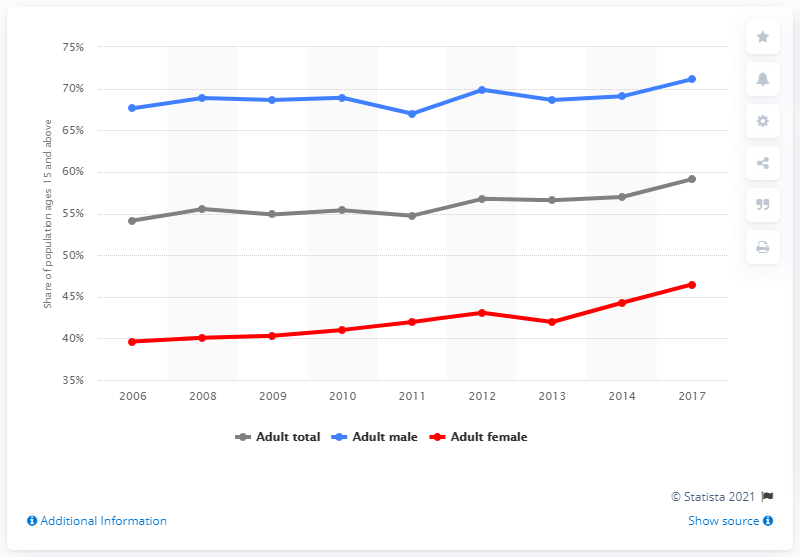Identify some key points in this picture. In 2017, Pakistan's total literacy rate was 59.13%. In 2017, the literacy rate among men in Pakistan was 71.12%. 